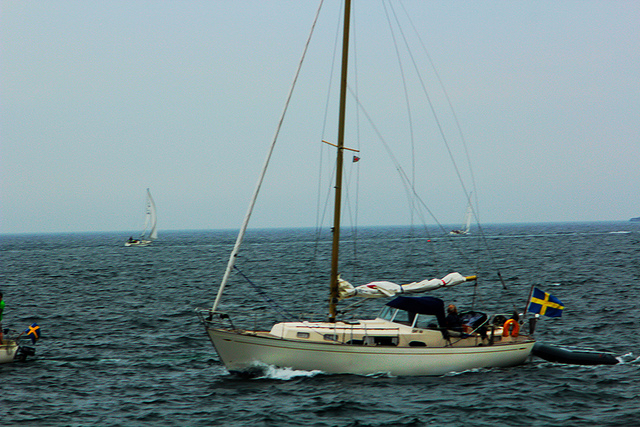<image>What nation's flag is flying on this boat? I don't know which nation's flag is flying on this boat. It can be Sweden, France, Norway, Finland or Switzerland. What nation's flag is flying on this boat? I don't know what nation's flag is flying on this boat. It can be either Sweden or France. 